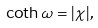Convert formula to latex. <formula><loc_0><loc_0><loc_500><loc_500>\coth \omega = | \chi | ,</formula> 